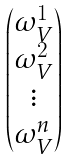Convert formula to latex. <formula><loc_0><loc_0><loc_500><loc_500>\begin{pmatrix} \omega ^ { 1 } _ { V } \\ \omega ^ { 2 } _ { V } \\ \vdots \\ \omega ^ { n } _ { V } \\ \end{pmatrix}</formula> 